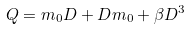<formula> <loc_0><loc_0><loc_500><loc_500>Q = m _ { 0 } D + D m _ { 0 } + \beta D ^ { 3 }</formula> 